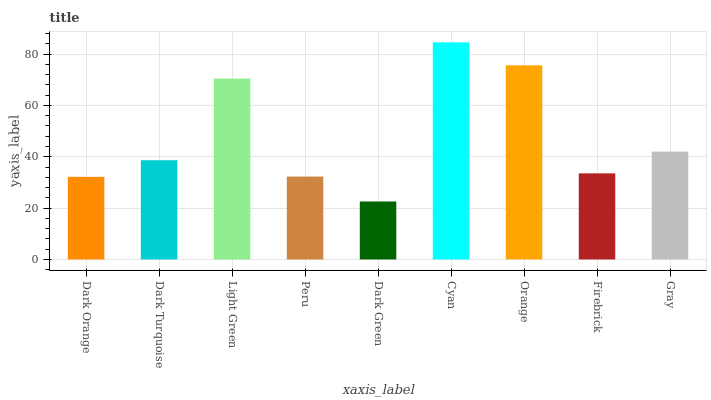Is Dark Turquoise the minimum?
Answer yes or no. No. Is Dark Turquoise the maximum?
Answer yes or no. No. Is Dark Turquoise greater than Dark Orange?
Answer yes or no. Yes. Is Dark Orange less than Dark Turquoise?
Answer yes or no. Yes. Is Dark Orange greater than Dark Turquoise?
Answer yes or no. No. Is Dark Turquoise less than Dark Orange?
Answer yes or no. No. Is Dark Turquoise the high median?
Answer yes or no. Yes. Is Dark Turquoise the low median?
Answer yes or no. Yes. Is Peru the high median?
Answer yes or no. No. Is Light Green the low median?
Answer yes or no. No. 